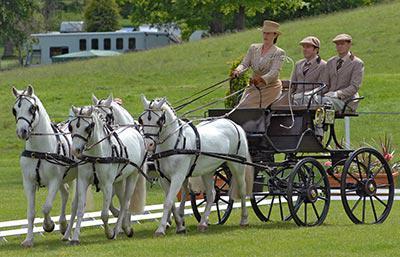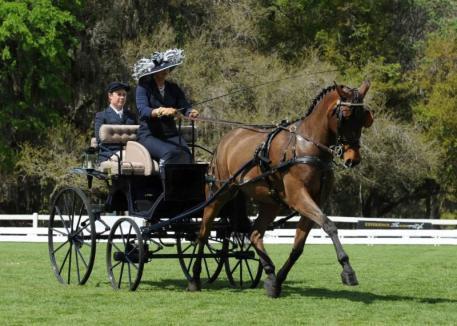The first image is the image on the left, the second image is the image on the right. For the images displayed, is the sentence "One cart with two wheels is driven by a man and one by a woman, each holding a whip, to control the single horse." factually correct? Answer yes or no. No. 